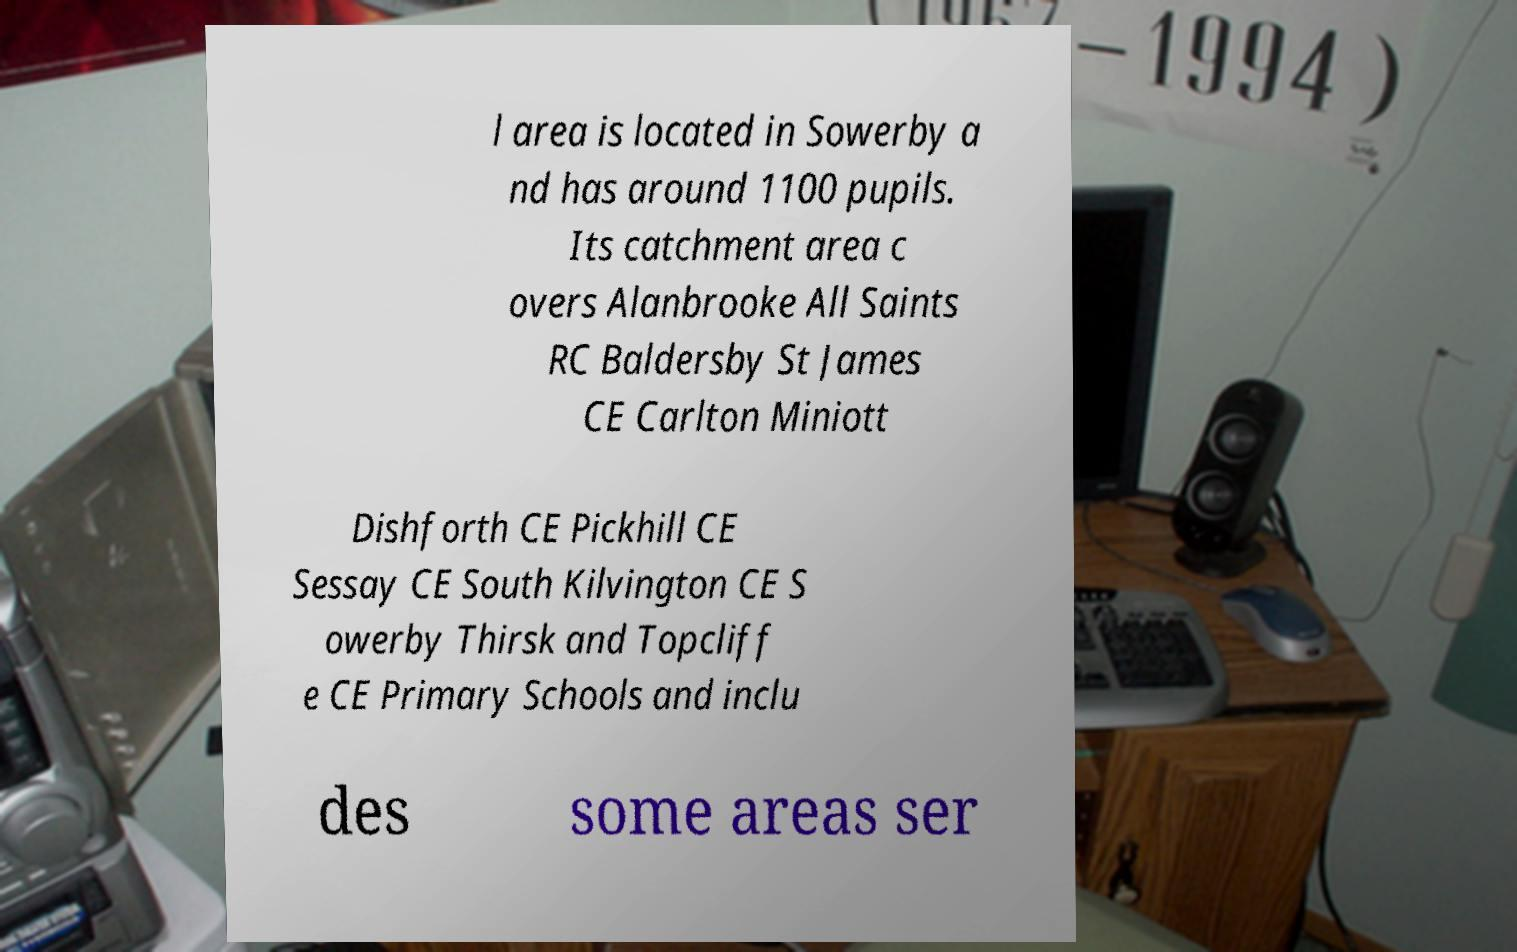What messages or text are displayed in this image? I need them in a readable, typed format. l area is located in Sowerby a nd has around 1100 pupils. Its catchment area c overs Alanbrooke All Saints RC Baldersby St James CE Carlton Miniott Dishforth CE Pickhill CE Sessay CE South Kilvington CE S owerby Thirsk and Topcliff e CE Primary Schools and inclu des some areas ser 